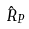Convert formula to latex. <formula><loc_0><loc_0><loc_500><loc_500>\hat { R } _ { P }</formula> 